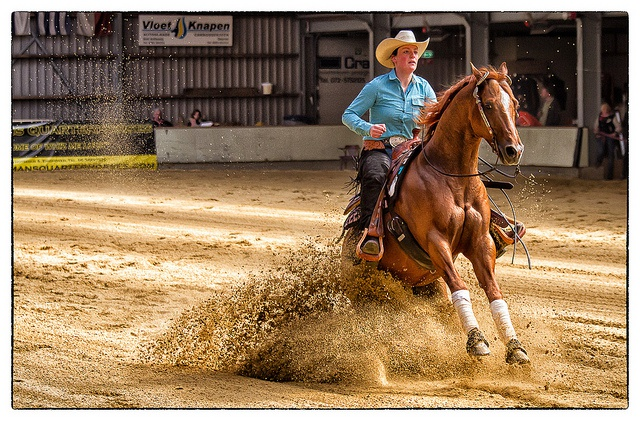Describe the objects in this image and their specific colors. I can see horse in white, maroon, black, brown, and tan tones, people in white, black, gray, maroon, and teal tones, people in white, black, maroon, and gray tones, people in white, black, maroon, and brown tones, and people in white, black, gray, maroon, and brown tones in this image. 